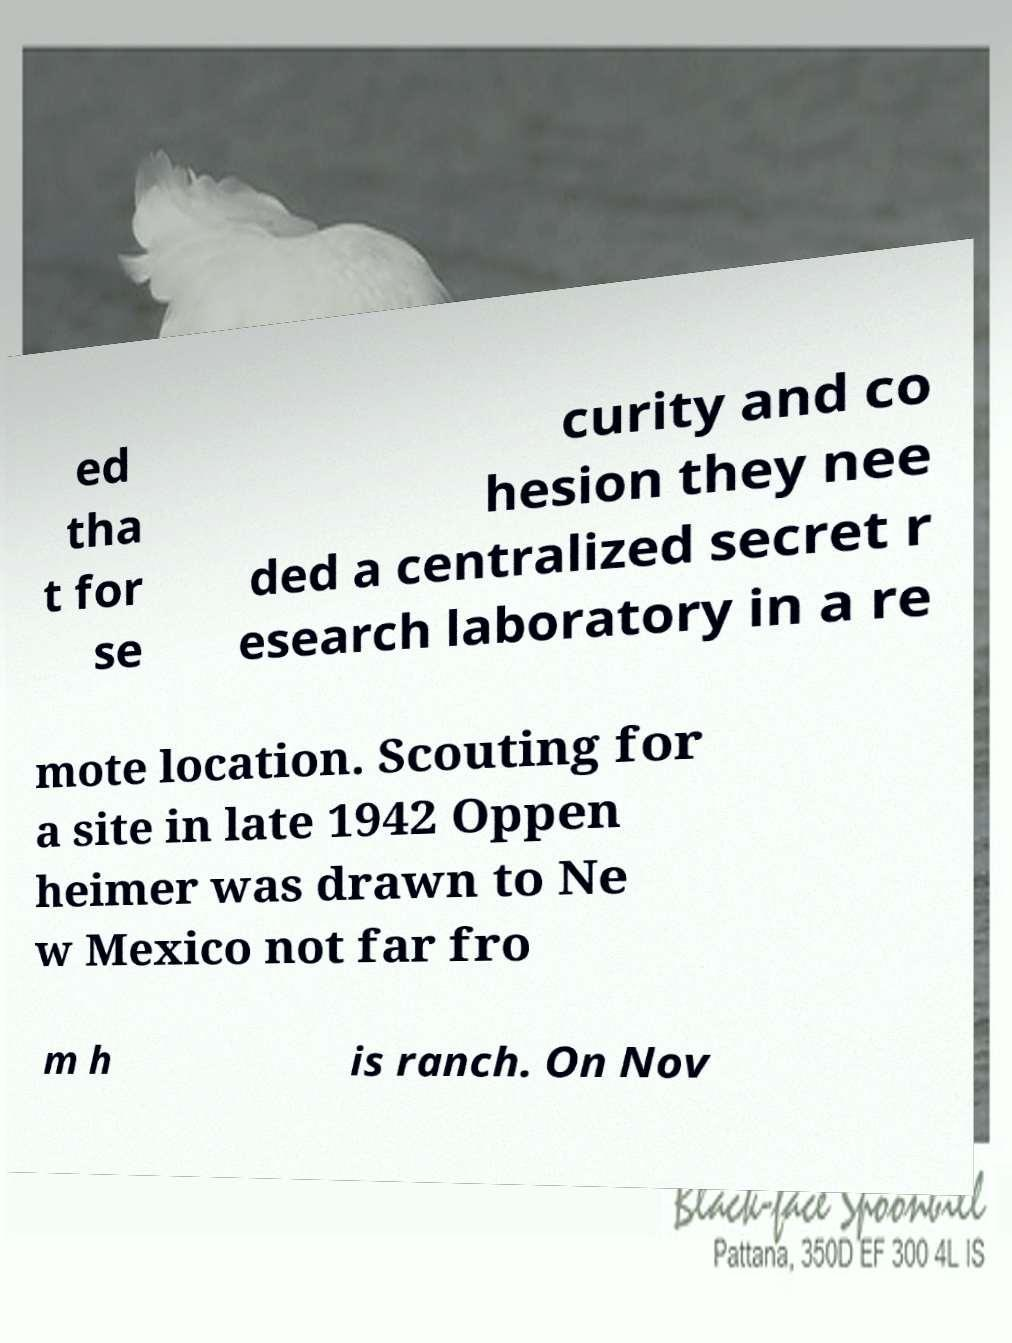Can you read and provide the text displayed in the image?This photo seems to have some interesting text. Can you extract and type it out for me? ed tha t for se curity and co hesion they nee ded a centralized secret r esearch laboratory in a re mote location. Scouting for a site in late 1942 Oppen heimer was drawn to Ne w Mexico not far fro m h is ranch. On Nov 